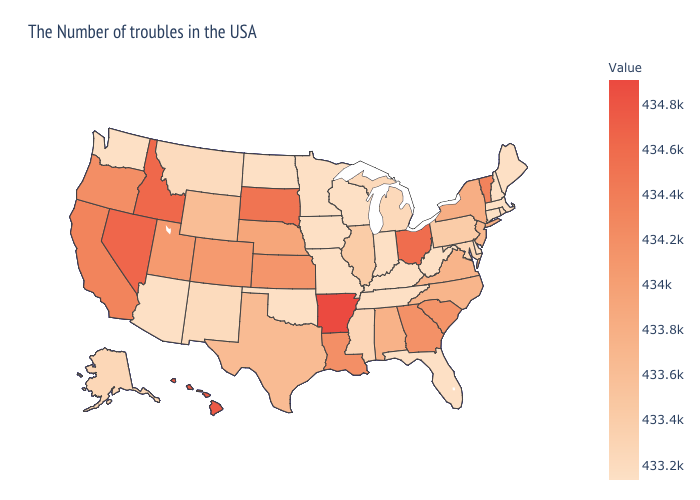Does Louisiana have a higher value than Idaho?
Be succinct. No. Does North Carolina have a lower value than Nevada?
Write a very short answer. Yes. Among the states that border Indiana , does Kentucky have the lowest value?
Keep it brief. Yes. Does Washington have a higher value than Pennsylvania?
Write a very short answer. No. Does Rhode Island have the lowest value in the Northeast?
Answer briefly. No. Does the map have missing data?
Give a very brief answer. No. 